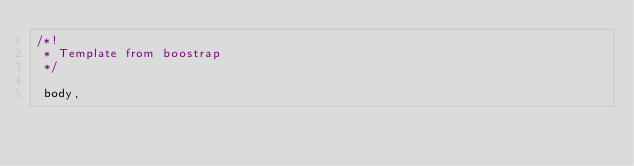Convert code to text. <code><loc_0><loc_0><loc_500><loc_500><_CSS_>/*!
 * Template from boostrap 
 */

 body,</code> 